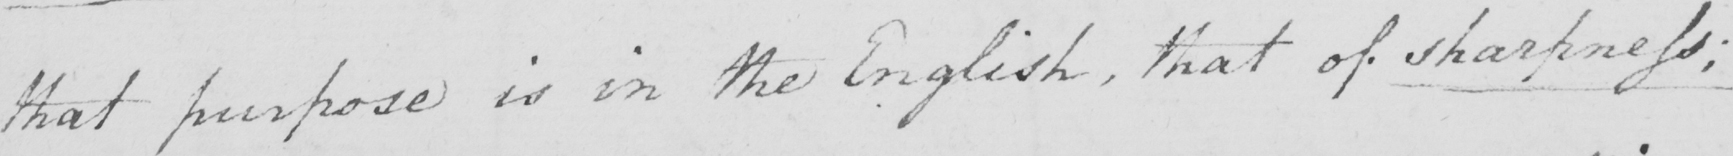What does this handwritten line say? that purpose is in the English , that of sharpness ; 